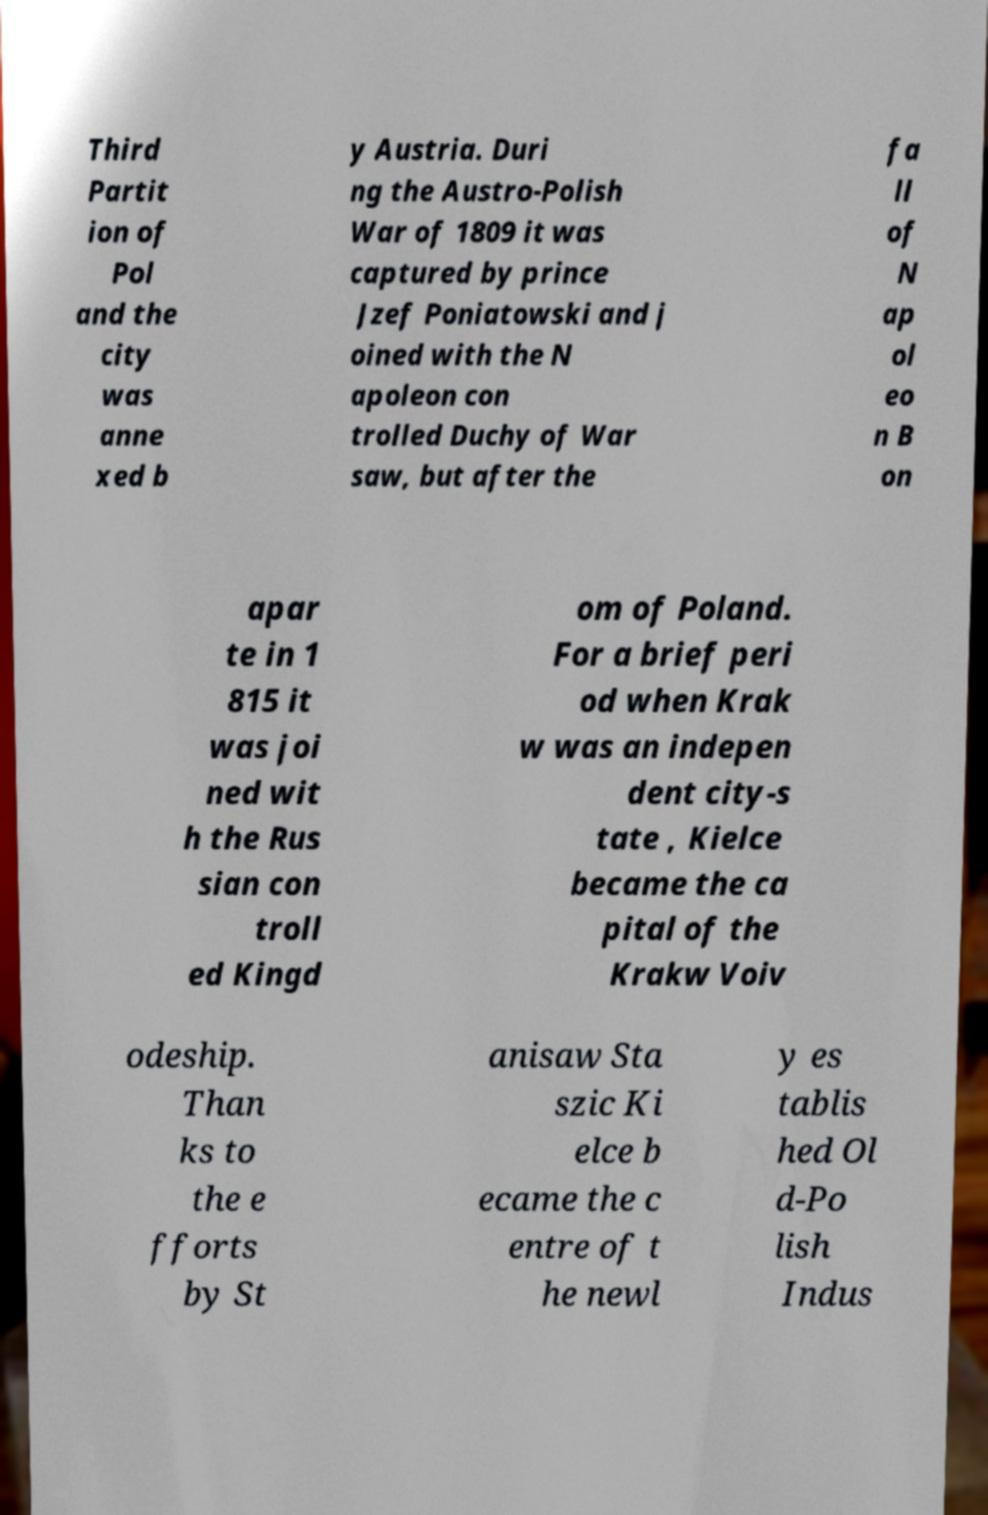Can you read and provide the text displayed in the image?This photo seems to have some interesting text. Can you extract and type it out for me? Third Partit ion of Pol and the city was anne xed b y Austria. Duri ng the Austro-Polish War of 1809 it was captured by prince Jzef Poniatowski and j oined with the N apoleon con trolled Duchy of War saw, but after the fa ll of N ap ol eo n B on apar te in 1 815 it was joi ned wit h the Rus sian con troll ed Kingd om of Poland. For a brief peri od when Krak w was an indepen dent city-s tate , Kielce became the ca pital of the Krakw Voiv odeship. Than ks to the e fforts by St anisaw Sta szic Ki elce b ecame the c entre of t he newl y es tablis hed Ol d-Po lish Indus 